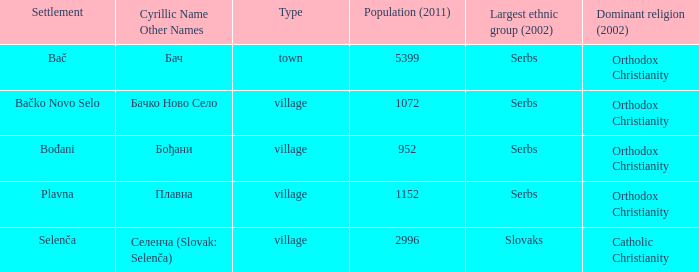What is the smallest population listed? 952.0. 